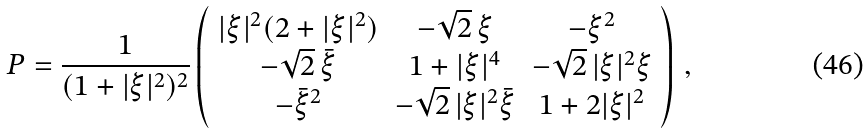<formula> <loc_0><loc_0><loc_500><loc_500>P = \frac { 1 } { ( 1 + | \xi | ^ { 2 } ) ^ { 2 } } \left ( \begin{array} { c c c } | \xi | ^ { 2 } ( 2 + | \xi | ^ { 2 } ) & - \sqrt { 2 } \, \xi & - \xi ^ { 2 } \\ - \sqrt { 2 } \, \bar { \xi } & 1 + | \xi | ^ { 4 } & - \sqrt { 2 } \, | \xi | ^ { 2 } \xi \\ - \bar { \xi } ^ { 2 } & - \sqrt { 2 } \, | \xi | ^ { 2 } \bar { \xi } & 1 + 2 | \xi | ^ { 2 } \end{array} \right ) \, ,</formula> 